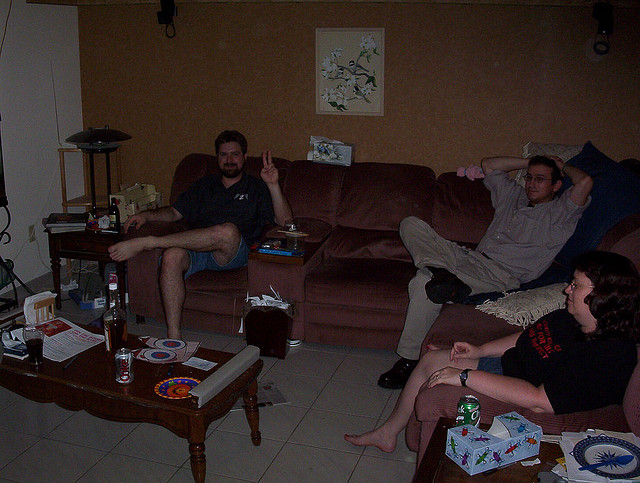<image>What is inside the blue box on the table? I don't know what exactly is inside the blue box on the table. Possible answers could be kleenex, socks, or tissues. What is written on the paper sitting on the table? I am not sure what's written on the paper sitting on the table. It could be a calendar, a phone number, an article, words, whiskey, or a grocery list. What is the blue paint pattern on the wall? I am not sure what the blue paint pattern on the wall is. It could be a painting or floral design. What leg is in the air? It is ambiguous which leg is in the air. It can be the left, right, or even both. Which side shoe does the man have off? It is uncertain which shoe the man has off. It could potentially be the right or the left. What is inside the blue box on the table? I am not sure what is inside the blue box on the table. It can be kleenex or tissues. What is the blue paint pattern on the wall? I cannot determine the exact blue paint pattern on the wall. It can be floral or a painting of some sort. What is written on the paper sitting on the table? I am not sure what is written on the paper sitting on the table. It can be seen 'nothing', 'calendar', 'phone number', 'article', 'words', 'whiskey' or 'grocery list'. What leg is in the air? It is ambiguous which leg is in the air. It can be both left or right. Which side shoe does the man have off? I am not sure which side shoe does the man have off. It can be either left or right. 